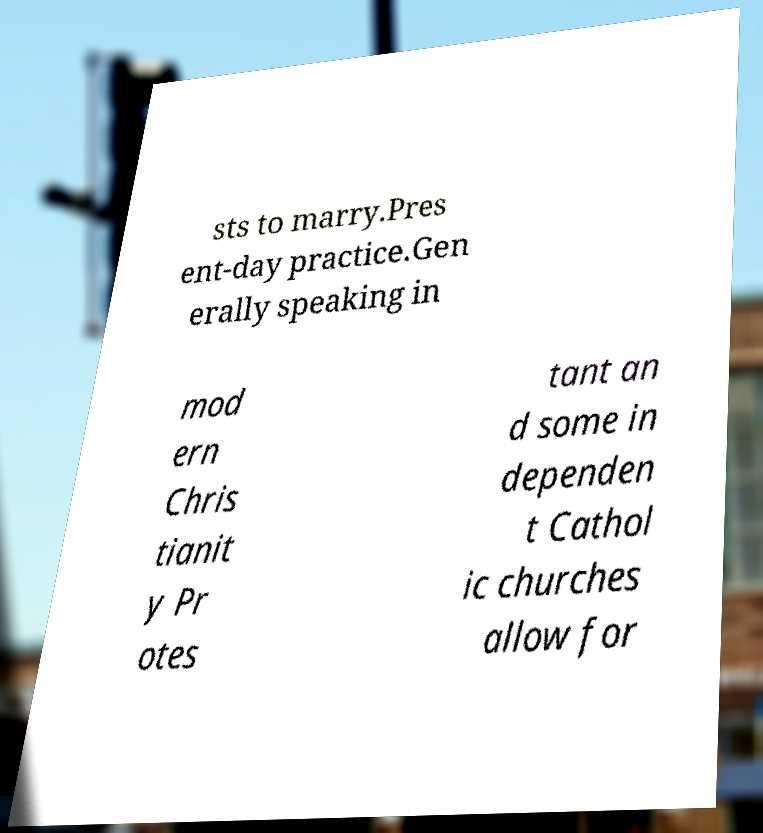Can you read and provide the text displayed in the image?This photo seems to have some interesting text. Can you extract and type it out for me? sts to marry.Pres ent-day practice.Gen erally speaking in mod ern Chris tianit y Pr otes tant an d some in dependen t Cathol ic churches allow for 